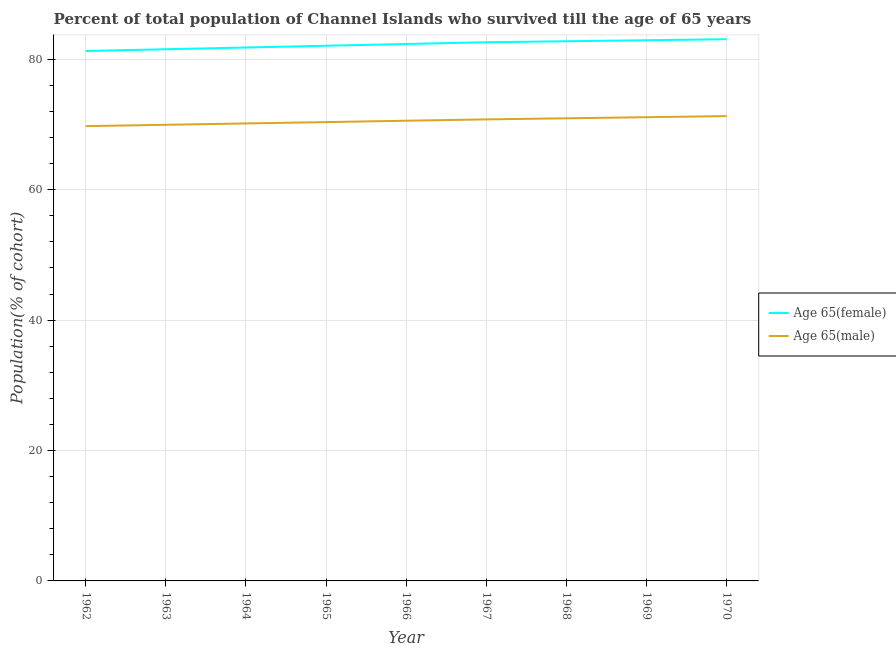How many different coloured lines are there?
Offer a very short reply. 2. Does the line corresponding to percentage of female population who survived till age of 65 intersect with the line corresponding to percentage of male population who survived till age of 65?
Keep it short and to the point. No. Is the number of lines equal to the number of legend labels?
Your answer should be compact. Yes. What is the percentage of female population who survived till age of 65 in 1964?
Provide a short and direct response. 81.82. Across all years, what is the maximum percentage of female population who survived till age of 65?
Offer a very short reply. 83.09. Across all years, what is the minimum percentage of male population who survived till age of 65?
Give a very brief answer. 69.76. In which year was the percentage of male population who survived till age of 65 maximum?
Your response must be concise. 1970. In which year was the percentage of male population who survived till age of 65 minimum?
Offer a very short reply. 1962. What is the total percentage of female population who survived till age of 65 in the graph?
Offer a very short reply. 740.54. What is the difference between the percentage of male population who survived till age of 65 in 1963 and that in 1966?
Ensure brevity in your answer.  -0.62. What is the difference between the percentage of female population who survived till age of 65 in 1965 and the percentage of male population who survived till age of 65 in 1970?
Provide a succinct answer. 10.79. What is the average percentage of male population who survived till age of 65 per year?
Make the answer very short. 70.56. In the year 1964, what is the difference between the percentage of male population who survived till age of 65 and percentage of female population who survived till age of 65?
Your response must be concise. -11.65. In how many years, is the percentage of female population who survived till age of 65 greater than 16 %?
Offer a very short reply. 9. What is the ratio of the percentage of male population who survived till age of 65 in 1963 to that in 1965?
Your response must be concise. 0.99. What is the difference between the highest and the second highest percentage of female population who survived till age of 65?
Your answer should be compact. 0.15. What is the difference between the highest and the lowest percentage of male population who survived till age of 65?
Your answer should be compact. 1.54. Is the sum of the percentage of female population who survived till age of 65 in 1962 and 1970 greater than the maximum percentage of male population who survived till age of 65 across all years?
Make the answer very short. Yes. Is the percentage of male population who survived till age of 65 strictly greater than the percentage of female population who survived till age of 65 over the years?
Give a very brief answer. No. Does the graph contain any zero values?
Make the answer very short. No. Does the graph contain grids?
Ensure brevity in your answer.  Yes. How many legend labels are there?
Your answer should be very brief. 2. How are the legend labels stacked?
Offer a terse response. Vertical. What is the title of the graph?
Provide a succinct answer. Percent of total population of Channel Islands who survived till the age of 65 years. What is the label or title of the X-axis?
Make the answer very short. Year. What is the label or title of the Y-axis?
Your answer should be very brief. Population(% of cohort). What is the Population(% of cohort) in Age 65(female) in 1962?
Ensure brevity in your answer.  81.28. What is the Population(% of cohort) in Age 65(male) in 1962?
Give a very brief answer. 69.76. What is the Population(% of cohort) of Age 65(female) in 1963?
Make the answer very short. 81.55. What is the Population(% of cohort) of Age 65(male) in 1963?
Your answer should be compact. 69.97. What is the Population(% of cohort) of Age 65(female) in 1964?
Your answer should be compact. 81.82. What is the Population(% of cohort) of Age 65(male) in 1964?
Your response must be concise. 70.17. What is the Population(% of cohort) in Age 65(female) in 1965?
Ensure brevity in your answer.  82.09. What is the Population(% of cohort) in Age 65(male) in 1965?
Keep it short and to the point. 70.38. What is the Population(% of cohort) of Age 65(female) in 1966?
Provide a succinct answer. 82.36. What is the Population(% of cohort) in Age 65(male) in 1966?
Your answer should be very brief. 70.59. What is the Population(% of cohort) of Age 65(female) in 1967?
Provide a succinct answer. 82.63. What is the Population(% of cohort) in Age 65(male) in 1967?
Offer a terse response. 70.79. What is the Population(% of cohort) of Age 65(female) in 1968?
Provide a succinct answer. 82.78. What is the Population(% of cohort) of Age 65(male) in 1968?
Ensure brevity in your answer.  70.96. What is the Population(% of cohort) of Age 65(female) in 1969?
Your answer should be compact. 82.94. What is the Population(% of cohort) of Age 65(male) in 1969?
Your answer should be compact. 71.13. What is the Population(% of cohort) in Age 65(female) in 1970?
Provide a short and direct response. 83.09. What is the Population(% of cohort) in Age 65(male) in 1970?
Your answer should be compact. 71.3. Across all years, what is the maximum Population(% of cohort) in Age 65(female)?
Ensure brevity in your answer.  83.09. Across all years, what is the maximum Population(% of cohort) of Age 65(male)?
Offer a very short reply. 71.3. Across all years, what is the minimum Population(% of cohort) of Age 65(female)?
Offer a terse response. 81.28. Across all years, what is the minimum Population(% of cohort) in Age 65(male)?
Ensure brevity in your answer.  69.76. What is the total Population(% of cohort) of Age 65(female) in the graph?
Give a very brief answer. 740.54. What is the total Population(% of cohort) of Age 65(male) in the graph?
Offer a very short reply. 635.05. What is the difference between the Population(% of cohort) of Age 65(female) in 1962 and that in 1963?
Your answer should be compact. -0.27. What is the difference between the Population(% of cohort) in Age 65(male) in 1962 and that in 1963?
Your answer should be very brief. -0.21. What is the difference between the Population(% of cohort) of Age 65(female) in 1962 and that in 1964?
Give a very brief answer. -0.54. What is the difference between the Population(% of cohort) in Age 65(male) in 1962 and that in 1964?
Your answer should be very brief. -0.41. What is the difference between the Population(% of cohort) of Age 65(female) in 1962 and that in 1965?
Provide a succinct answer. -0.81. What is the difference between the Population(% of cohort) in Age 65(male) in 1962 and that in 1965?
Your answer should be very brief. -0.62. What is the difference between the Population(% of cohort) of Age 65(female) in 1962 and that in 1966?
Keep it short and to the point. -1.07. What is the difference between the Population(% of cohort) in Age 65(male) in 1962 and that in 1966?
Make the answer very short. -0.83. What is the difference between the Population(% of cohort) in Age 65(female) in 1962 and that in 1967?
Your response must be concise. -1.34. What is the difference between the Population(% of cohort) of Age 65(male) in 1962 and that in 1967?
Make the answer very short. -1.04. What is the difference between the Population(% of cohort) in Age 65(female) in 1962 and that in 1968?
Keep it short and to the point. -1.5. What is the difference between the Population(% of cohort) of Age 65(male) in 1962 and that in 1968?
Give a very brief answer. -1.2. What is the difference between the Population(% of cohort) in Age 65(female) in 1962 and that in 1969?
Offer a terse response. -1.65. What is the difference between the Population(% of cohort) in Age 65(male) in 1962 and that in 1969?
Make the answer very short. -1.37. What is the difference between the Population(% of cohort) in Age 65(female) in 1962 and that in 1970?
Your answer should be compact. -1.81. What is the difference between the Population(% of cohort) of Age 65(male) in 1962 and that in 1970?
Offer a very short reply. -1.54. What is the difference between the Population(% of cohort) in Age 65(female) in 1963 and that in 1964?
Keep it short and to the point. -0.27. What is the difference between the Population(% of cohort) of Age 65(male) in 1963 and that in 1964?
Your response must be concise. -0.21. What is the difference between the Population(% of cohort) of Age 65(female) in 1963 and that in 1965?
Make the answer very short. -0.54. What is the difference between the Population(% of cohort) in Age 65(male) in 1963 and that in 1965?
Give a very brief answer. -0.41. What is the difference between the Population(% of cohort) of Age 65(female) in 1963 and that in 1966?
Offer a very short reply. -0.81. What is the difference between the Population(% of cohort) in Age 65(male) in 1963 and that in 1966?
Offer a very short reply. -0.62. What is the difference between the Population(% of cohort) in Age 65(female) in 1963 and that in 1967?
Provide a succinct answer. -1.07. What is the difference between the Population(% of cohort) of Age 65(male) in 1963 and that in 1967?
Ensure brevity in your answer.  -0.83. What is the difference between the Population(% of cohort) in Age 65(female) in 1963 and that in 1968?
Keep it short and to the point. -1.23. What is the difference between the Population(% of cohort) in Age 65(male) in 1963 and that in 1968?
Ensure brevity in your answer.  -1. What is the difference between the Population(% of cohort) in Age 65(female) in 1963 and that in 1969?
Provide a short and direct response. -1.38. What is the difference between the Population(% of cohort) in Age 65(male) in 1963 and that in 1969?
Provide a short and direct response. -1.16. What is the difference between the Population(% of cohort) of Age 65(female) in 1963 and that in 1970?
Your response must be concise. -1.54. What is the difference between the Population(% of cohort) in Age 65(male) in 1963 and that in 1970?
Keep it short and to the point. -1.33. What is the difference between the Population(% of cohort) in Age 65(female) in 1964 and that in 1965?
Your response must be concise. -0.27. What is the difference between the Population(% of cohort) in Age 65(male) in 1964 and that in 1965?
Your answer should be very brief. -0.21. What is the difference between the Population(% of cohort) in Age 65(female) in 1964 and that in 1966?
Make the answer very short. -0.54. What is the difference between the Population(% of cohort) in Age 65(male) in 1964 and that in 1966?
Keep it short and to the point. -0.41. What is the difference between the Population(% of cohort) of Age 65(female) in 1964 and that in 1967?
Offer a terse response. -0.81. What is the difference between the Population(% of cohort) in Age 65(male) in 1964 and that in 1967?
Your response must be concise. -0.62. What is the difference between the Population(% of cohort) in Age 65(female) in 1964 and that in 1968?
Provide a succinct answer. -0.96. What is the difference between the Population(% of cohort) of Age 65(male) in 1964 and that in 1968?
Your answer should be compact. -0.79. What is the difference between the Population(% of cohort) of Age 65(female) in 1964 and that in 1969?
Provide a short and direct response. -1.11. What is the difference between the Population(% of cohort) in Age 65(male) in 1964 and that in 1969?
Offer a very short reply. -0.96. What is the difference between the Population(% of cohort) in Age 65(female) in 1964 and that in 1970?
Ensure brevity in your answer.  -1.27. What is the difference between the Population(% of cohort) in Age 65(male) in 1964 and that in 1970?
Your answer should be compact. -1.12. What is the difference between the Population(% of cohort) in Age 65(female) in 1965 and that in 1966?
Offer a very short reply. -0.27. What is the difference between the Population(% of cohort) of Age 65(male) in 1965 and that in 1966?
Keep it short and to the point. -0.21. What is the difference between the Population(% of cohort) of Age 65(female) in 1965 and that in 1967?
Provide a succinct answer. -0.54. What is the difference between the Population(% of cohort) in Age 65(male) in 1965 and that in 1967?
Ensure brevity in your answer.  -0.41. What is the difference between the Population(% of cohort) in Age 65(female) in 1965 and that in 1968?
Your answer should be compact. -0.69. What is the difference between the Population(% of cohort) of Age 65(male) in 1965 and that in 1968?
Make the answer very short. -0.58. What is the difference between the Population(% of cohort) of Age 65(female) in 1965 and that in 1969?
Your answer should be compact. -0.85. What is the difference between the Population(% of cohort) in Age 65(male) in 1965 and that in 1969?
Your answer should be compact. -0.75. What is the difference between the Population(% of cohort) in Age 65(female) in 1965 and that in 1970?
Provide a succinct answer. -1. What is the difference between the Population(% of cohort) of Age 65(male) in 1965 and that in 1970?
Offer a terse response. -0.92. What is the difference between the Population(% of cohort) in Age 65(female) in 1966 and that in 1967?
Keep it short and to the point. -0.27. What is the difference between the Population(% of cohort) in Age 65(male) in 1966 and that in 1967?
Offer a very short reply. -0.21. What is the difference between the Population(% of cohort) of Age 65(female) in 1966 and that in 1968?
Make the answer very short. -0.42. What is the difference between the Population(% of cohort) of Age 65(male) in 1966 and that in 1968?
Give a very brief answer. -0.37. What is the difference between the Population(% of cohort) in Age 65(female) in 1966 and that in 1969?
Ensure brevity in your answer.  -0.58. What is the difference between the Population(% of cohort) in Age 65(male) in 1966 and that in 1969?
Provide a succinct answer. -0.54. What is the difference between the Population(% of cohort) in Age 65(female) in 1966 and that in 1970?
Ensure brevity in your answer.  -0.73. What is the difference between the Population(% of cohort) in Age 65(male) in 1966 and that in 1970?
Offer a very short reply. -0.71. What is the difference between the Population(% of cohort) of Age 65(female) in 1967 and that in 1968?
Offer a terse response. -0.15. What is the difference between the Population(% of cohort) in Age 65(male) in 1967 and that in 1968?
Offer a terse response. -0.17. What is the difference between the Population(% of cohort) in Age 65(female) in 1967 and that in 1969?
Your answer should be compact. -0.31. What is the difference between the Population(% of cohort) in Age 65(male) in 1967 and that in 1969?
Give a very brief answer. -0.33. What is the difference between the Population(% of cohort) of Age 65(female) in 1967 and that in 1970?
Provide a succinct answer. -0.46. What is the difference between the Population(% of cohort) in Age 65(male) in 1967 and that in 1970?
Keep it short and to the point. -0.5. What is the difference between the Population(% of cohort) of Age 65(female) in 1968 and that in 1969?
Give a very brief answer. -0.15. What is the difference between the Population(% of cohort) of Age 65(male) in 1968 and that in 1969?
Your response must be concise. -0.17. What is the difference between the Population(% of cohort) in Age 65(female) in 1968 and that in 1970?
Offer a terse response. -0.31. What is the difference between the Population(% of cohort) in Age 65(male) in 1968 and that in 1970?
Provide a short and direct response. -0.33. What is the difference between the Population(% of cohort) of Age 65(female) in 1969 and that in 1970?
Keep it short and to the point. -0.15. What is the difference between the Population(% of cohort) in Age 65(male) in 1969 and that in 1970?
Offer a terse response. -0.17. What is the difference between the Population(% of cohort) of Age 65(female) in 1962 and the Population(% of cohort) of Age 65(male) in 1963?
Keep it short and to the point. 11.32. What is the difference between the Population(% of cohort) in Age 65(female) in 1962 and the Population(% of cohort) in Age 65(male) in 1964?
Offer a very short reply. 11.11. What is the difference between the Population(% of cohort) in Age 65(female) in 1962 and the Population(% of cohort) in Age 65(male) in 1965?
Your answer should be very brief. 10.9. What is the difference between the Population(% of cohort) in Age 65(female) in 1962 and the Population(% of cohort) in Age 65(male) in 1966?
Offer a terse response. 10.7. What is the difference between the Population(% of cohort) in Age 65(female) in 1962 and the Population(% of cohort) in Age 65(male) in 1967?
Keep it short and to the point. 10.49. What is the difference between the Population(% of cohort) of Age 65(female) in 1962 and the Population(% of cohort) of Age 65(male) in 1968?
Offer a terse response. 10.32. What is the difference between the Population(% of cohort) in Age 65(female) in 1962 and the Population(% of cohort) in Age 65(male) in 1969?
Provide a short and direct response. 10.16. What is the difference between the Population(% of cohort) of Age 65(female) in 1962 and the Population(% of cohort) of Age 65(male) in 1970?
Offer a very short reply. 9.99. What is the difference between the Population(% of cohort) of Age 65(female) in 1963 and the Population(% of cohort) of Age 65(male) in 1964?
Provide a succinct answer. 11.38. What is the difference between the Population(% of cohort) of Age 65(female) in 1963 and the Population(% of cohort) of Age 65(male) in 1965?
Provide a succinct answer. 11.17. What is the difference between the Population(% of cohort) in Age 65(female) in 1963 and the Population(% of cohort) in Age 65(male) in 1966?
Make the answer very short. 10.97. What is the difference between the Population(% of cohort) in Age 65(female) in 1963 and the Population(% of cohort) in Age 65(male) in 1967?
Your answer should be very brief. 10.76. What is the difference between the Population(% of cohort) in Age 65(female) in 1963 and the Population(% of cohort) in Age 65(male) in 1968?
Keep it short and to the point. 10.59. What is the difference between the Population(% of cohort) in Age 65(female) in 1963 and the Population(% of cohort) in Age 65(male) in 1969?
Make the answer very short. 10.42. What is the difference between the Population(% of cohort) of Age 65(female) in 1963 and the Population(% of cohort) of Age 65(male) in 1970?
Give a very brief answer. 10.26. What is the difference between the Population(% of cohort) in Age 65(female) in 1964 and the Population(% of cohort) in Age 65(male) in 1965?
Your answer should be compact. 11.44. What is the difference between the Population(% of cohort) of Age 65(female) in 1964 and the Population(% of cohort) of Age 65(male) in 1966?
Give a very brief answer. 11.23. What is the difference between the Population(% of cohort) in Age 65(female) in 1964 and the Population(% of cohort) in Age 65(male) in 1967?
Provide a short and direct response. 11.03. What is the difference between the Population(% of cohort) in Age 65(female) in 1964 and the Population(% of cohort) in Age 65(male) in 1968?
Offer a terse response. 10.86. What is the difference between the Population(% of cohort) in Age 65(female) in 1964 and the Population(% of cohort) in Age 65(male) in 1969?
Your response must be concise. 10.69. What is the difference between the Population(% of cohort) of Age 65(female) in 1964 and the Population(% of cohort) of Age 65(male) in 1970?
Your response must be concise. 10.53. What is the difference between the Population(% of cohort) of Age 65(female) in 1965 and the Population(% of cohort) of Age 65(male) in 1966?
Ensure brevity in your answer.  11.5. What is the difference between the Population(% of cohort) of Age 65(female) in 1965 and the Population(% of cohort) of Age 65(male) in 1967?
Give a very brief answer. 11.3. What is the difference between the Population(% of cohort) in Age 65(female) in 1965 and the Population(% of cohort) in Age 65(male) in 1968?
Make the answer very short. 11.13. What is the difference between the Population(% of cohort) of Age 65(female) in 1965 and the Population(% of cohort) of Age 65(male) in 1969?
Your answer should be very brief. 10.96. What is the difference between the Population(% of cohort) of Age 65(female) in 1965 and the Population(% of cohort) of Age 65(male) in 1970?
Keep it short and to the point. 10.79. What is the difference between the Population(% of cohort) in Age 65(female) in 1966 and the Population(% of cohort) in Age 65(male) in 1967?
Make the answer very short. 11.56. What is the difference between the Population(% of cohort) in Age 65(female) in 1966 and the Population(% of cohort) in Age 65(male) in 1968?
Keep it short and to the point. 11.4. What is the difference between the Population(% of cohort) in Age 65(female) in 1966 and the Population(% of cohort) in Age 65(male) in 1969?
Give a very brief answer. 11.23. What is the difference between the Population(% of cohort) in Age 65(female) in 1966 and the Population(% of cohort) in Age 65(male) in 1970?
Offer a very short reply. 11.06. What is the difference between the Population(% of cohort) in Age 65(female) in 1967 and the Population(% of cohort) in Age 65(male) in 1968?
Your response must be concise. 11.66. What is the difference between the Population(% of cohort) in Age 65(female) in 1967 and the Population(% of cohort) in Age 65(male) in 1969?
Provide a short and direct response. 11.5. What is the difference between the Population(% of cohort) in Age 65(female) in 1967 and the Population(% of cohort) in Age 65(male) in 1970?
Keep it short and to the point. 11.33. What is the difference between the Population(% of cohort) in Age 65(female) in 1968 and the Population(% of cohort) in Age 65(male) in 1969?
Provide a succinct answer. 11.65. What is the difference between the Population(% of cohort) in Age 65(female) in 1968 and the Population(% of cohort) in Age 65(male) in 1970?
Keep it short and to the point. 11.48. What is the difference between the Population(% of cohort) in Age 65(female) in 1969 and the Population(% of cohort) in Age 65(male) in 1970?
Ensure brevity in your answer.  11.64. What is the average Population(% of cohort) in Age 65(female) per year?
Your answer should be very brief. 82.28. What is the average Population(% of cohort) of Age 65(male) per year?
Give a very brief answer. 70.56. In the year 1962, what is the difference between the Population(% of cohort) of Age 65(female) and Population(% of cohort) of Age 65(male)?
Offer a very short reply. 11.53. In the year 1963, what is the difference between the Population(% of cohort) of Age 65(female) and Population(% of cohort) of Age 65(male)?
Ensure brevity in your answer.  11.59. In the year 1964, what is the difference between the Population(% of cohort) of Age 65(female) and Population(% of cohort) of Age 65(male)?
Offer a very short reply. 11.65. In the year 1965, what is the difference between the Population(% of cohort) of Age 65(female) and Population(% of cohort) of Age 65(male)?
Your answer should be very brief. 11.71. In the year 1966, what is the difference between the Population(% of cohort) in Age 65(female) and Population(% of cohort) in Age 65(male)?
Your response must be concise. 11.77. In the year 1967, what is the difference between the Population(% of cohort) of Age 65(female) and Population(% of cohort) of Age 65(male)?
Give a very brief answer. 11.83. In the year 1968, what is the difference between the Population(% of cohort) of Age 65(female) and Population(% of cohort) of Age 65(male)?
Provide a succinct answer. 11.82. In the year 1969, what is the difference between the Population(% of cohort) of Age 65(female) and Population(% of cohort) of Age 65(male)?
Provide a short and direct response. 11.81. In the year 1970, what is the difference between the Population(% of cohort) of Age 65(female) and Population(% of cohort) of Age 65(male)?
Offer a very short reply. 11.79. What is the ratio of the Population(% of cohort) of Age 65(female) in 1962 to that in 1963?
Ensure brevity in your answer.  1. What is the ratio of the Population(% of cohort) in Age 65(male) in 1962 to that in 1963?
Ensure brevity in your answer.  1. What is the ratio of the Population(% of cohort) of Age 65(female) in 1962 to that in 1965?
Your response must be concise. 0.99. What is the ratio of the Population(% of cohort) of Age 65(male) in 1962 to that in 1966?
Offer a very short reply. 0.99. What is the ratio of the Population(% of cohort) of Age 65(female) in 1962 to that in 1967?
Your response must be concise. 0.98. What is the ratio of the Population(% of cohort) of Age 65(male) in 1962 to that in 1967?
Provide a succinct answer. 0.99. What is the ratio of the Population(% of cohort) in Age 65(female) in 1962 to that in 1968?
Ensure brevity in your answer.  0.98. What is the ratio of the Population(% of cohort) in Age 65(male) in 1962 to that in 1968?
Ensure brevity in your answer.  0.98. What is the ratio of the Population(% of cohort) in Age 65(female) in 1962 to that in 1969?
Provide a succinct answer. 0.98. What is the ratio of the Population(% of cohort) in Age 65(male) in 1962 to that in 1969?
Ensure brevity in your answer.  0.98. What is the ratio of the Population(% of cohort) in Age 65(female) in 1962 to that in 1970?
Offer a very short reply. 0.98. What is the ratio of the Population(% of cohort) in Age 65(male) in 1962 to that in 1970?
Your answer should be compact. 0.98. What is the ratio of the Population(% of cohort) of Age 65(female) in 1963 to that in 1964?
Give a very brief answer. 1. What is the ratio of the Population(% of cohort) of Age 65(male) in 1963 to that in 1965?
Your answer should be very brief. 0.99. What is the ratio of the Population(% of cohort) of Age 65(female) in 1963 to that in 1966?
Keep it short and to the point. 0.99. What is the ratio of the Population(% of cohort) of Age 65(female) in 1963 to that in 1967?
Give a very brief answer. 0.99. What is the ratio of the Population(% of cohort) of Age 65(male) in 1963 to that in 1967?
Keep it short and to the point. 0.99. What is the ratio of the Population(% of cohort) in Age 65(female) in 1963 to that in 1968?
Provide a succinct answer. 0.99. What is the ratio of the Population(% of cohort) in Age 65(female) in 1963 to that in 1969?
Give a very brief answer. 0.98. What is the ratio of the Population(% of cohort) in Age 65(male) in 1963 to that in 1969?
Make the answer very short. 0.98. What is the ratio of the Population(% of cohort) of Age 65(female) in 1963 to that in 1970?
Provide a short and direct response. 0.98. What is the ratio of the Population(% of cohort) of Age 65(male) in 1963 to that in 1970?
Make the answer very short. 0.98. What is the ratio of the Population(% of cohort) of Age 65(female) in 1964 to that in 1967?
Your response must be concise. 0.99. What is the ratio of the Population(% of cohort) in Age 65(female) in 1964 to that in 1968?
Make the answer very short. 0.99. What is the ratio of the Population(% of cohort) in Age 65(male) in 1964 to that in 1968?
Keep it short and to the point. 0.99. What is the ratio of the Population(% of cohort) of Age 65(female) in 1964 to that in 1969?
Give a very brief answer. 0.99. What is the ratio of the Population(% of cohort) of Age 65(male) in 1964 to that in 1969?
Offer a very short reply. 0.99. What is the ratio of the Population(% of cohort) in Age 65(female) in 1964 to that in 1970?
Give a very brief answer. 0.98. What is the ratio of the Population(% of cohort) of Age 65(male) in 1964 to that in 1970?
Offer a terse response. 0.98. What is the ratio of the Population(% of cohort) of Age 65(male) in 1965 to that in 1966?
Offer a very short reply. 1. What is the ratio of the Population(% of cohort) of Age 65(male) in 1965 to that in 1967?
Your answer should be compact. 0.99. What is the ratio of the Population(% of cohort) of Age 65(female) in 1965 to that in 1968?
Keep it short and to the point. 0.99. What is the ratio of the Population(% of cohort) in Age 65(male) in 1965 to that in 1968?
Provide a succinct answer. 0.99. What is the ratio of the Population(% of cohort) in Age 65(female) in 1965 to that in 1970?
Provide a short and direct response. 0.99. What is the ratio of the Population(% of cohort) of Age 65(male) in 1965 to that in 1970?
Offer a terse response. 0.99. What is the ratio of the Population(% of cohort) in Age 65(male) in 1966 to that in 1968?
Ensure brevity in your answer.  0.99. What is the ratio of the Population(% of cohort) of Age 65(male) in 1966 to that in 1969?
Give a very brief answer. 0.99. What is the ratio of the Population(% of cohort) in Age 65(male) in 1966 to that in 1970?
Give a very brief answer. 0.99. What is the ratio of the Population(% of cohort) of Age 65(female) in 1967 to that in 1968?
Offer a very short reply. 1. What is the ratio of the Population(% of cohort) of Age 65(male) in 1967 to that in 1969?
Your answer should be compact. 1. What is the ratio of the Population(% of cohort) of Age 65(female) in 1967 to that in 1970?
Ensure brevity in your answer.  0.99. What is the ratio of the Population(% of cohort) of Age 65(male) in 1968 to that in 1969?
Give a very brief answer. 1. What is the difference between the highest and the second highest Population(% of cohort) in Age 65(female)?
Keep it short and to the point. 0.15. What is the difference between the highest and the second highest Population(% of cohort) in Age 65(male)?
Your response must be concise. 0.17. What is the difference between the highest and the lowest Population(% of cohort) of Age 65(female)?
Provide a succinct answer. 1.81. What is the difference between the highest and the lowest Population(% of cohort) in Age 65(male)?
Provide a succinct answer. 1.54. 